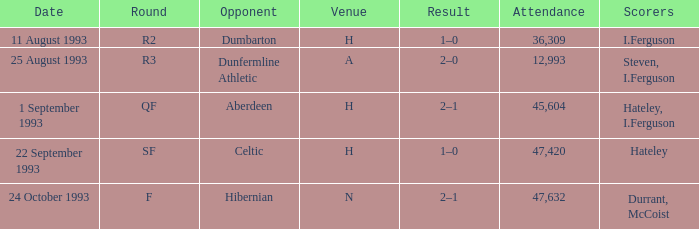What result is found for the round that has f? 2–1. 